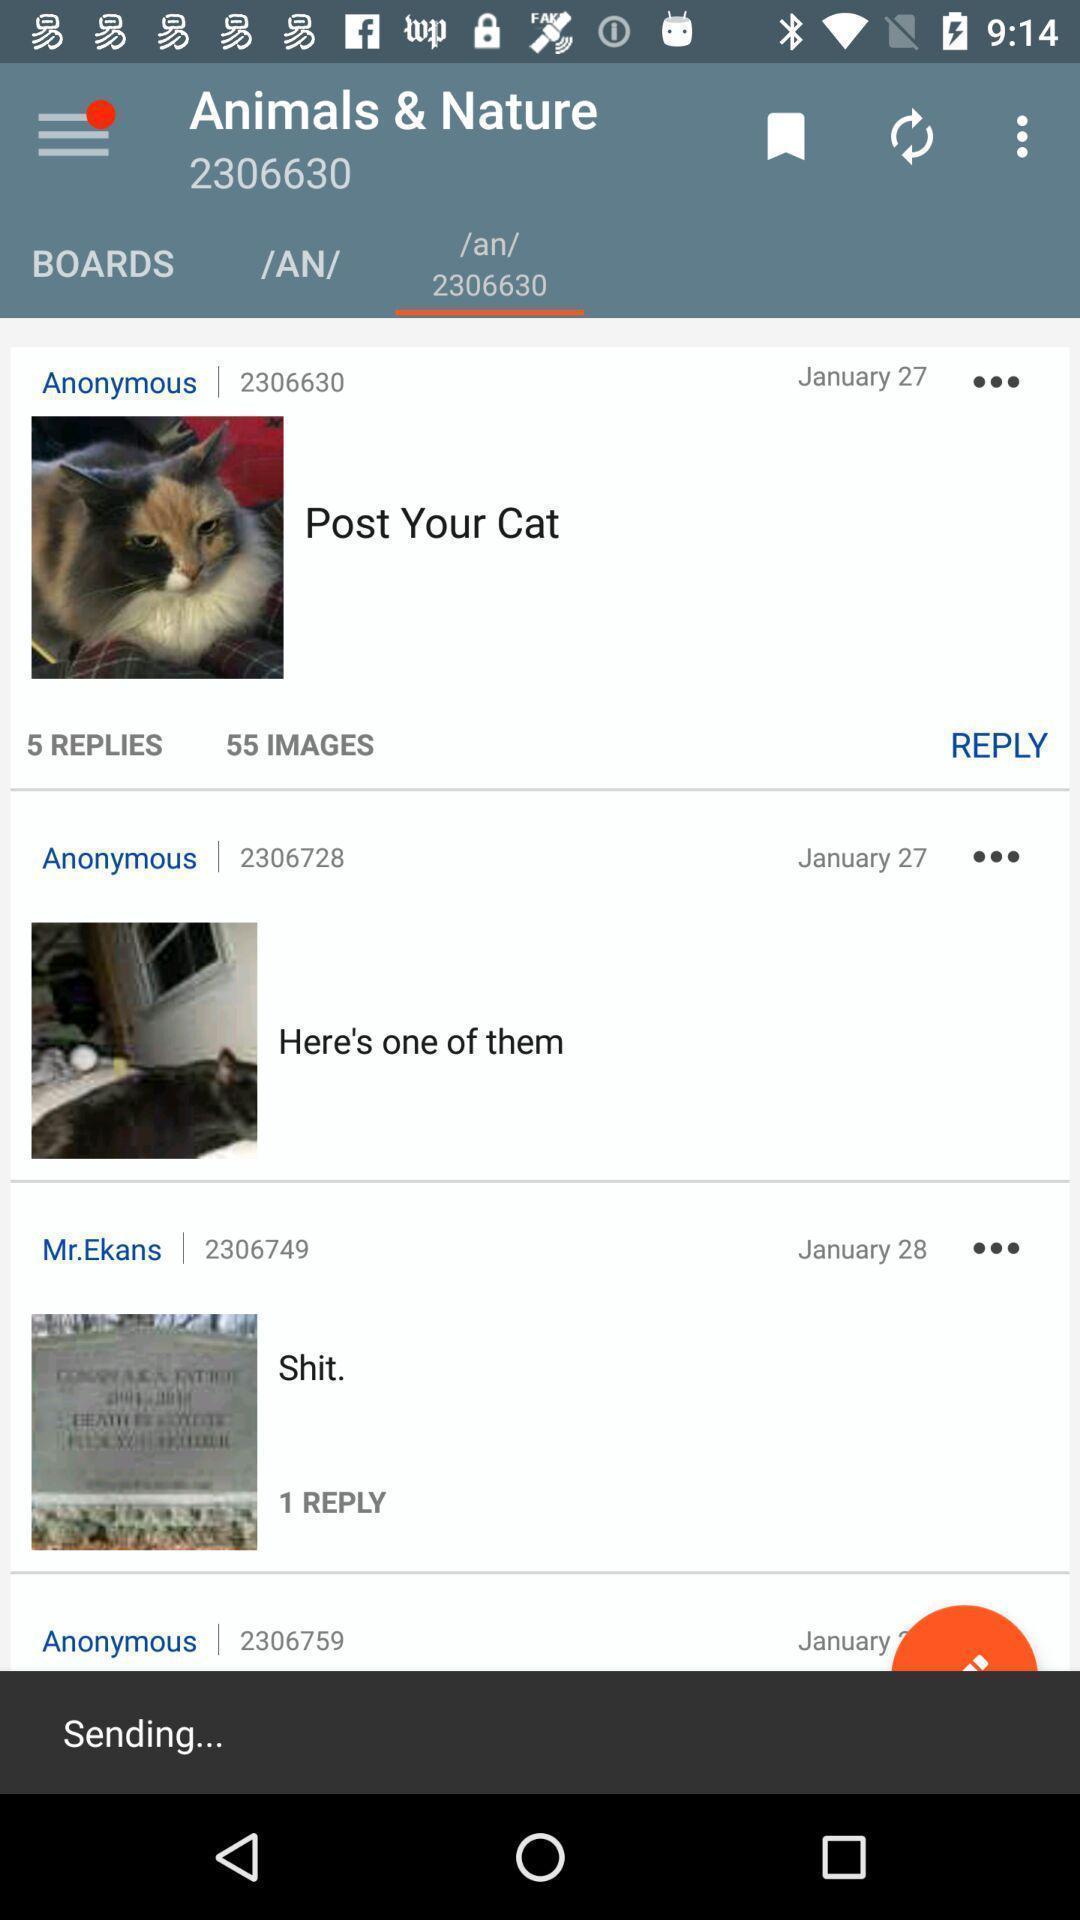Describe the visual elements of this screenshot. Various options. 